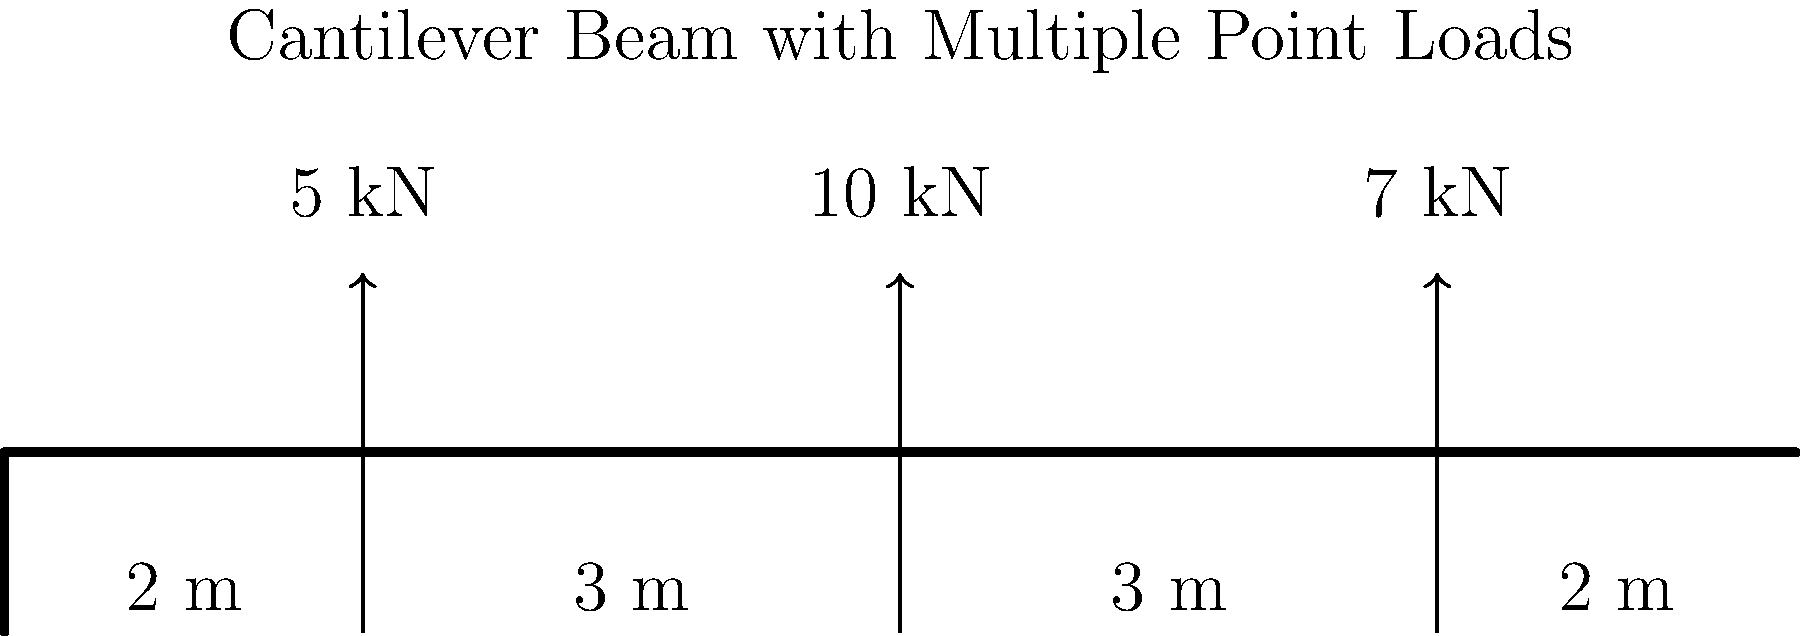For the cantilever beam shown in the figure, calculate the maximum bending moment and determine its location. How does this problem relate to the concept of stress distribution in structural analysis? To solve this problem and understand its relation to stress distribution, let's follow these steps:

1) First, we need to calculate the reactions at the fixed end:
   
   Vertical reaction: $R_y = 5 + 10 + 7 = 22$ kN (upward)
   Moment reaction: $M = (5 \times 8) + (10 \times 5) + (7 \times 2) = 40 + 50 + 14 = 104$ kN·m (clockwise)

2) Now, let's analyze the shear force diagram:
   
   - From 0 to 2 m: Constant shear of 22 kN
   - At 2 m: Drops by 7 kN to 15 kN
   - From 2 to 5 m: Constant shear of 15 kN
   - At 5 m: Drops by 10 kN to 5 kN
   - From 5 to 8 m: Constant shear of 5 kN
   - At 8 m: Drops by 5 kN to 0

3) For the bending moment diagram:
   
   - At 0 m: 104 kN·m
   - At 2 m: 104 - (22 × 2) = 60 kN·m
   - At 5 m: 60 - (15 × 3) = 15 kN·m
   - At 8 m: 15 - (5 × 3) = 0 kN·m

4) The maximum bending moment occurs at the fixed end (0 m) and is 104 kN·m.

5) Relation to stress distribution:
   
   The bending moment diagram directly relates to the stress distribution in the beam. According to the flexure formula, the maximum normal stress due to bending (σ) is proportional to the bending moment (M):

   $$ \sigma = \frac{My}{I} $$

   where y is the distance from the neutral axis, and I is the moment of inertia of the cross-section.

   Therefore, the point of maximum bending moment (the fixed end in this case) is also the point of maximum normal stress due to bending. This information is crucial for structural engineers when designing beams to ensure they can withstand the induced stresses without failure.

   Moreover, the change in bending moment along the beam indicates how the stress distribution varies along the length of the beam, providing insights into potential weak points or areas that require reinforcement.
Answer: Maximum bending moment: 104 kN·m at the fixed end (0 m). This corresponds to the location of maximum normal stress due to bending. 